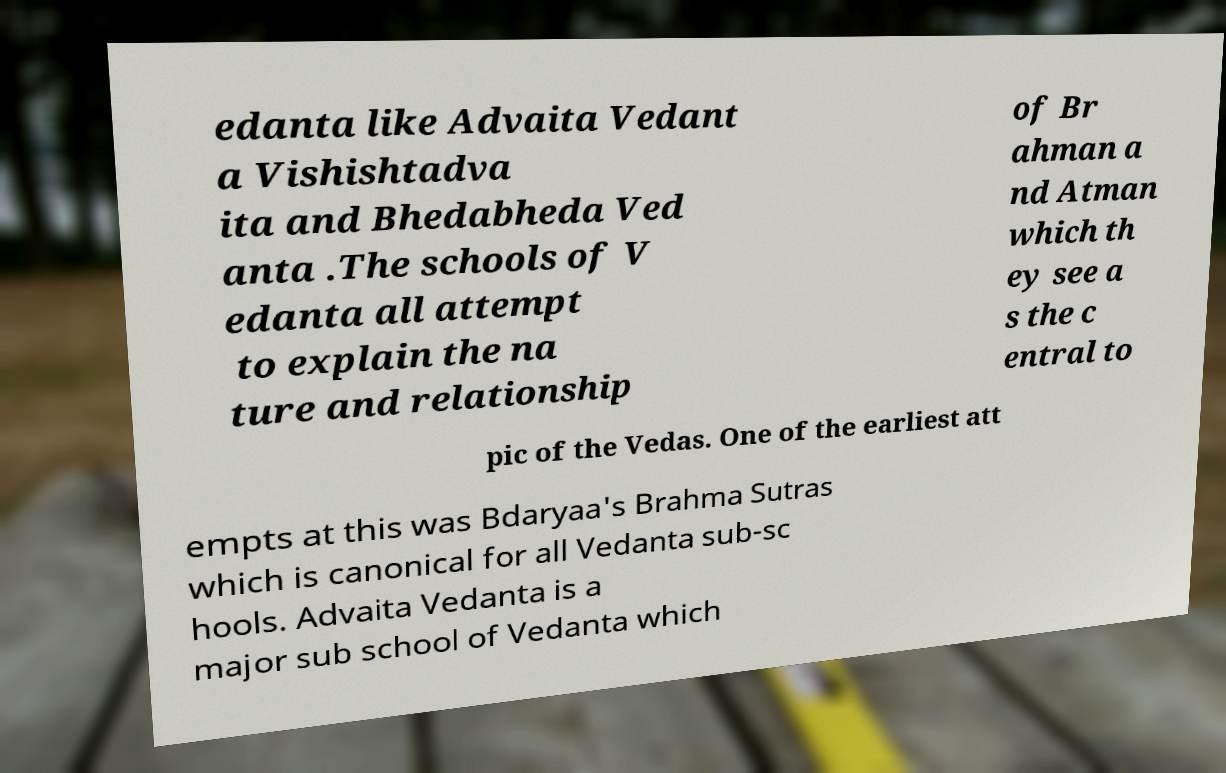What messages or text are displayed in this image? I need them in a readable, typed format. edanta like Advaita Vedant a Vishishtadva ita and Bhedabheda Ved anta .The schools of V edanta all attempt to explain the na ture and relationship of Br ahman a nd Atman which th ey see a s the c entral to pic of the Vedas. One of the earliest att empts at this was Bdaryaa's Brahma Sutras which is canonical for all Vedanta sub-sc hools. Advaita Vedanta is a major sub school of Vedanta which 